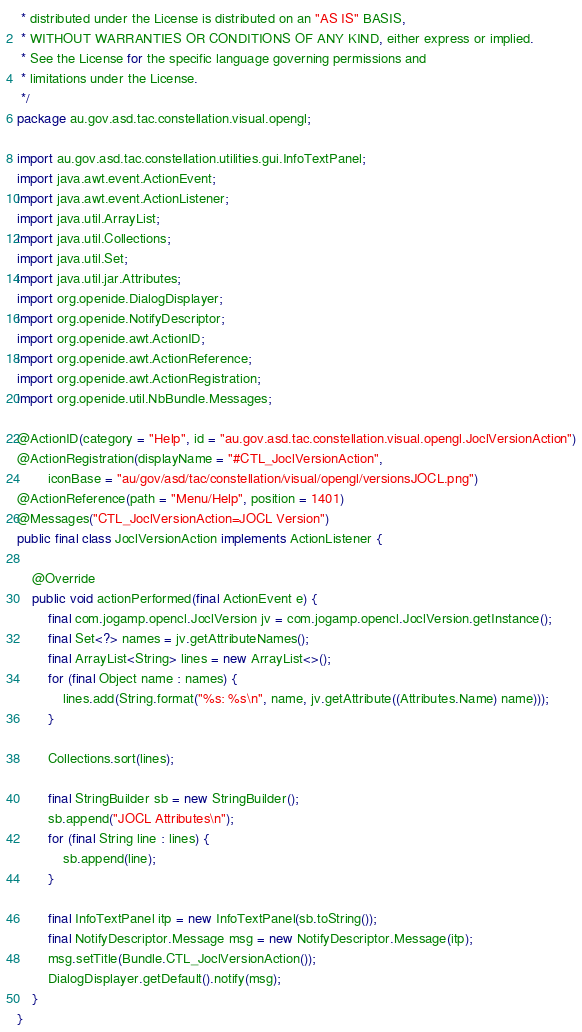Convert code to text. <code><loc_0><loc_0><loc_500><loc_500><_Java_> * distributed under the License is distributed on an "AS IS" BASIS,
 * WITHOUT WARRANTIES OR CONDITIONS OF ANY KIND, either express or implied.
 * See the License for the specific language governing permissions and
 * limitations under the License.
 */
package au.gov.asd.tac.constellation.visual.opengl;

import au.gov.asd.tac.constellation.utilities.gui.InfoTextPanel;
import java.awt.event.ActionEvent;
import java.awt.event.ActionListener;
import java.util.ArrayList;
import java.util.Collections;
import java.util.Set;
import java.util.jar.Attributes;
import org.openide.DialogDisplayer;
import org.openide.NotifyDescriptor;
import org.openide.awt.ActionID;
import org.openide.awt.ActionReference;
import org.openide.awt.ActionRegistration;
import org.openide.util.NbBundle.Messages;

@ActionID(category = "Help", id = "au.gov.asd.tac.constellation.visual.opengl.JoclVersionAction")
@ActionRegistration(displayName = "#CTL_JoclVersionAction",
        iconBase = "au/gov/asd/tac/constellation/visual/opengl/versionsJOCL.png")
@ActionReference(path = "Menu/Help", position = 1401)
@Messages("CTL_JoclVersionAction=JOCL Version")
public final class JoclVersionAction implements ActionListener {

    @Override
    public void actionPerformed(final ActionEvent e) {
        final com.jogamp.opencl.JoclVersion jv = com.jogamp.opencl.JoclVersion.getInstance();
        final Set<?> names = jv.getAttributeNames();
        final ArrayList<String> lines = new ArrayList<>();
        for (final Object name : names) {
            lines.add(String.format("%s: %s\n", name, jv.getAttribute((Attributes.Name) name)));
        }

        Collections.sort(lines);

        final StringBuilder sb = new StringBuilder();
        sb.append("JOCL Attributes\n");
        for (final String line : lines) {
            sb.append(line);
        }

        final InfoTextPanel itp = new InfoTextPanel(sb.toString());
        final NotifyDescriptor.Message msg = new NotifyDescriptor.Message(itp);
        msg.setTitle(Bundle.CTL_JoclVersionAction());
        DialogDisplayer.getDefault().notify(msg);
    }
}
</code> 